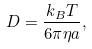<formula> <loc_0><loc_0><loc_500><loc_500>D = \frac { k _ { B } T } { 6 \pi \eta a } ,</formula> 